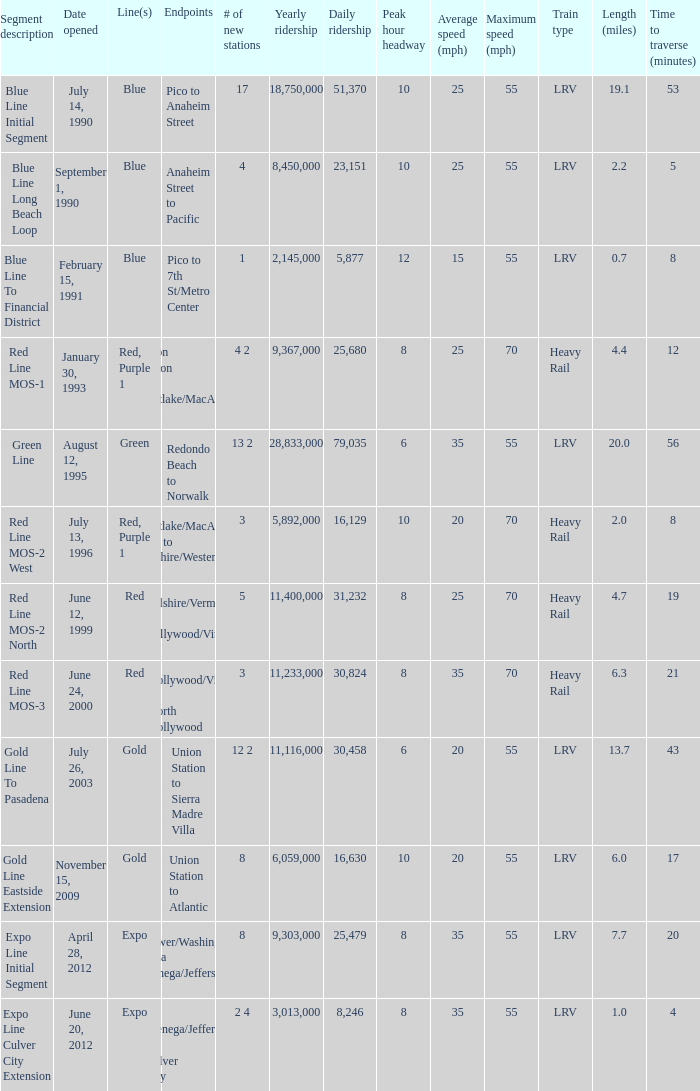What is the lenth (miles) of endpoints westlake/macarthur park to wilshire/western? 2.0. 